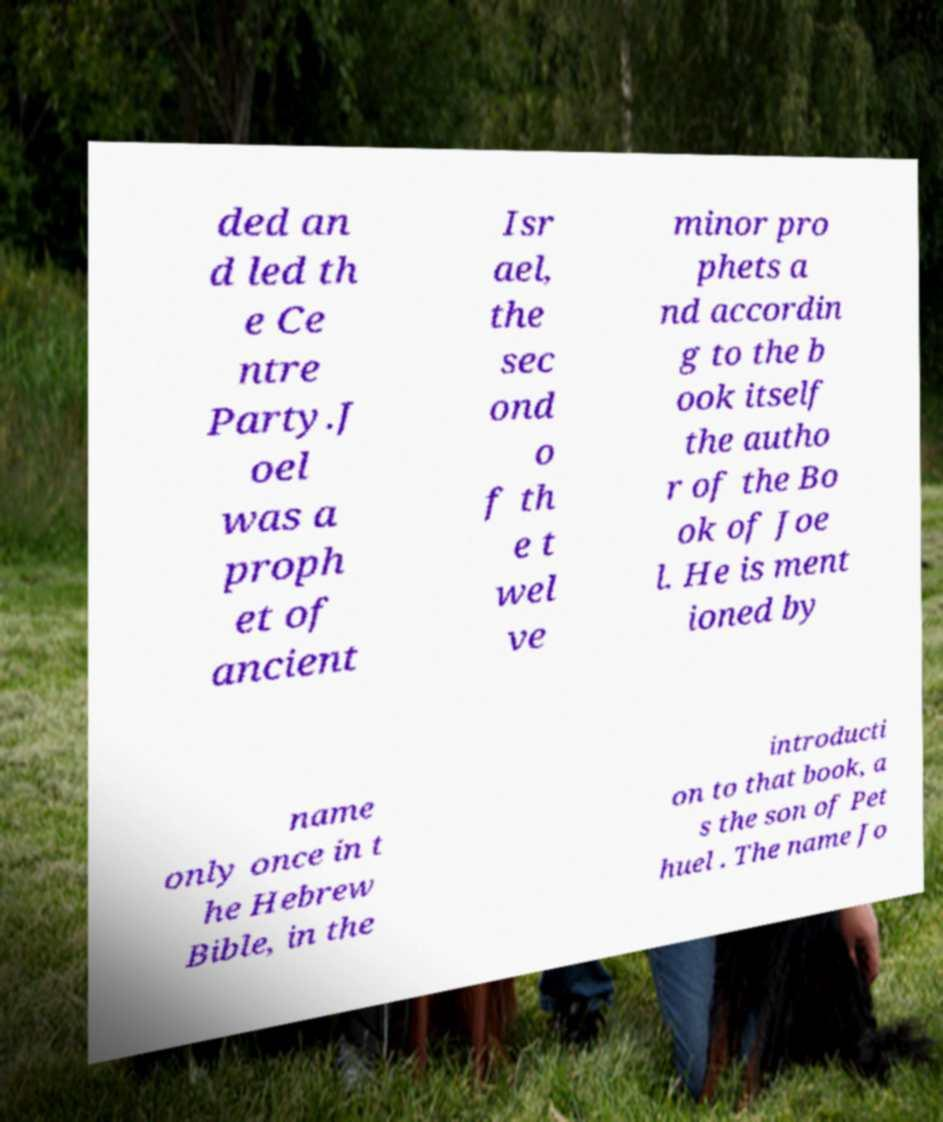Please read and relay the text visible in this image. What does it say? ded an d led th e Ce ntre Party.J oel was a proph et of ancient Isr ael, the sec ond o f th e t wel ve minor pro phets a nd accordin g to the b ook itself the autho r of the Bo ok of Joe l. He is ment ioned by name only once in t he Hebrew Bible, in the introducti on to that book, a s the son of Pet huel . The name Jo 